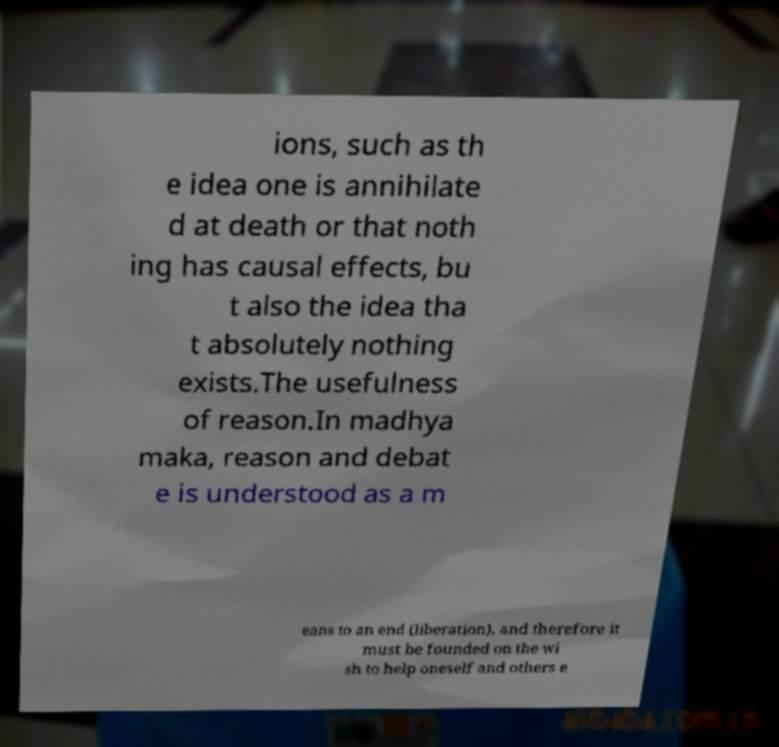Please identify and transcribe the text found in this image. ions, such as th e idea one is annihilate d at death or that noth ing has causal effects, bu t also the idea tha t absolutely nothing exists.The usefulness of reason.In madhya maka, reason and debat e is understood as a m eans to an end (liberation), and therefore it must be founded on the wi sh to help oneself and others e 